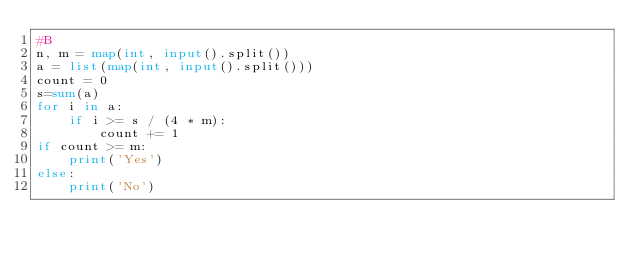<code> <loc_0><loc_0><loc_500><loc_500><_Python_>#B
n, m = map(int, input().split())
a = list(map(int, input().split()))
count = 0
s=sum(a)
for i in a:
    if i >= s / (4 * m):
        count += 1
if count >= m:
    print('Yes')
else:
    print('No')</code> 